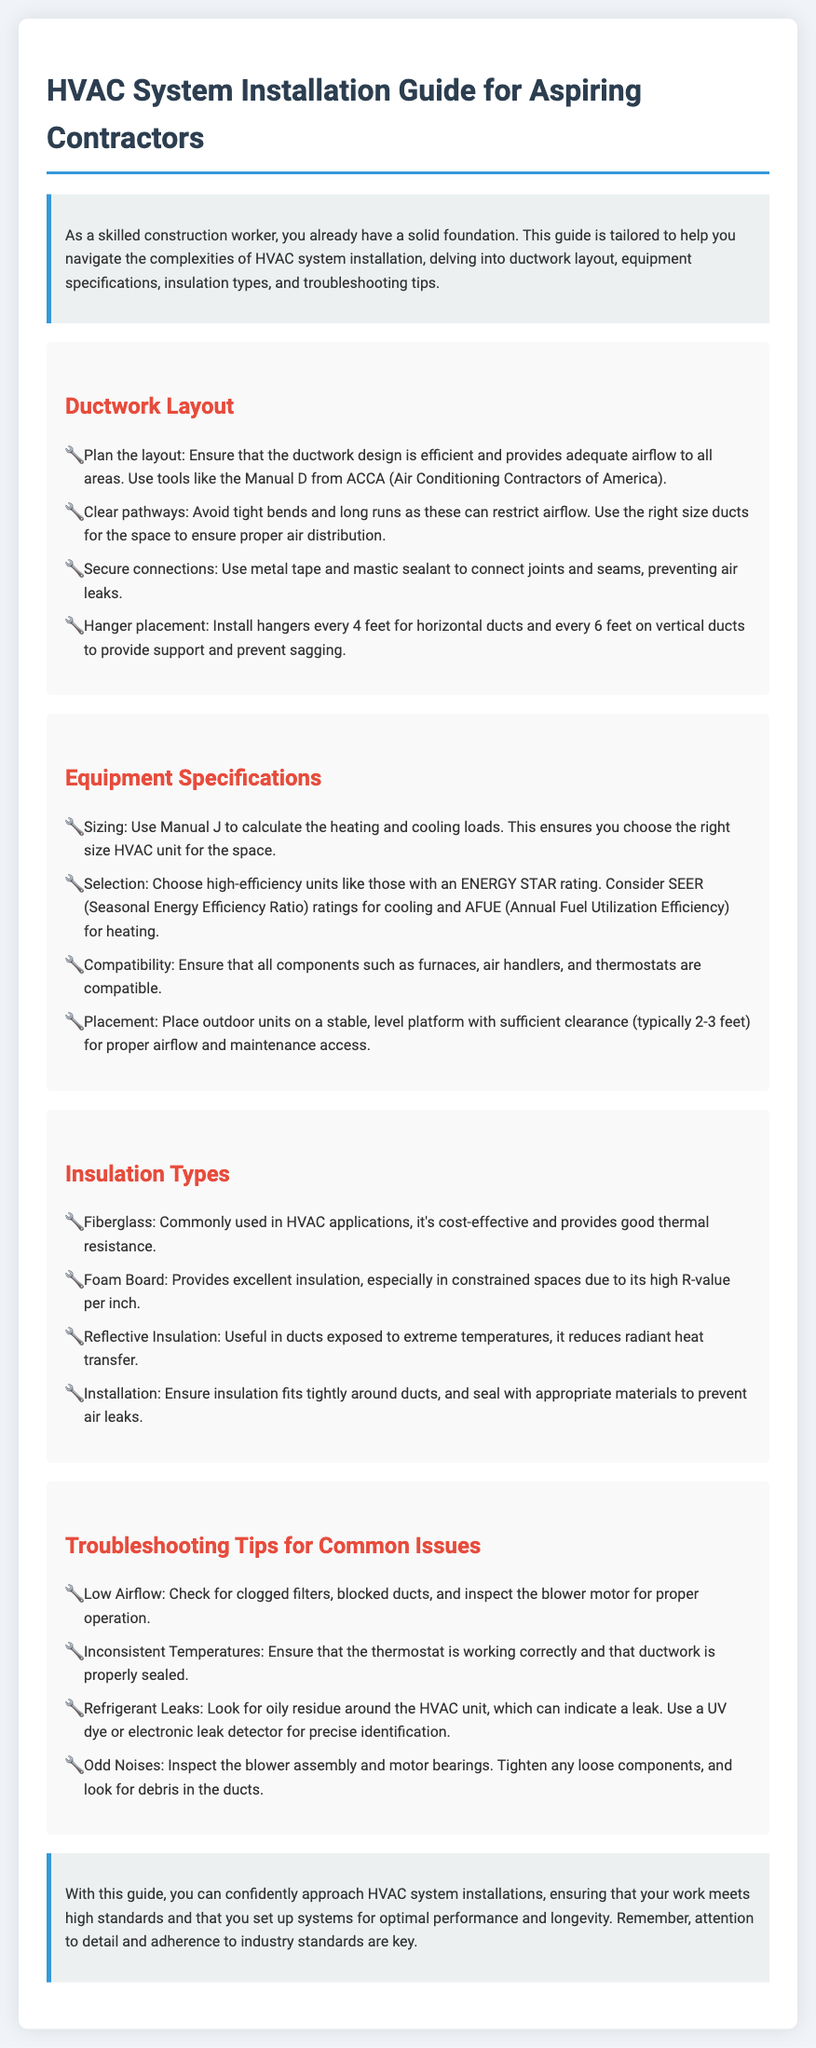What is the title of the guide? The title of the guide is explicit in the document header, which states its purpose.
Answer: HVAC System Installation Guide for Aspiring Contractors What organization provides a tool for ductwork design? The document references a specific organization that supplies tools for ductwork design.
Answer: ACCA What type of insulation is commonly used in HVAC applications? The document lists various insulation types, indicating which one is prevalent in HVAC systems.
Answer: Fiberglass How far apart should hangers be installed for horizontal ducts? The document specifies the correct distance for hangers in a specific scenario.
Answer: 4 feet What is the recommended clearance for outdoor units? The document expresses the necessary clearance for outdoor units for proper airflow.
Answer: 2-3 feet Which insulation type provides excellent insulation in constrained spaces? The document highlights an insulation type known for its efficiency in tight areas.
Answer: Foam Board What should be checked for low airflow issues? The document identifies potential causes for low airflow that need to be examined.
Answer: Clogged filters What measurement does Manual J help calculate? The document states a specific calculation that Manual J assists with, crucial for HVAC sizing.
Answer: Heating and cooling loads What is a key characteristic of high-efficiency units as mentioned in the guide? The document describes a specific feature that distinguishes high-efficiency units.
Answer: ENERGY STAR rating 